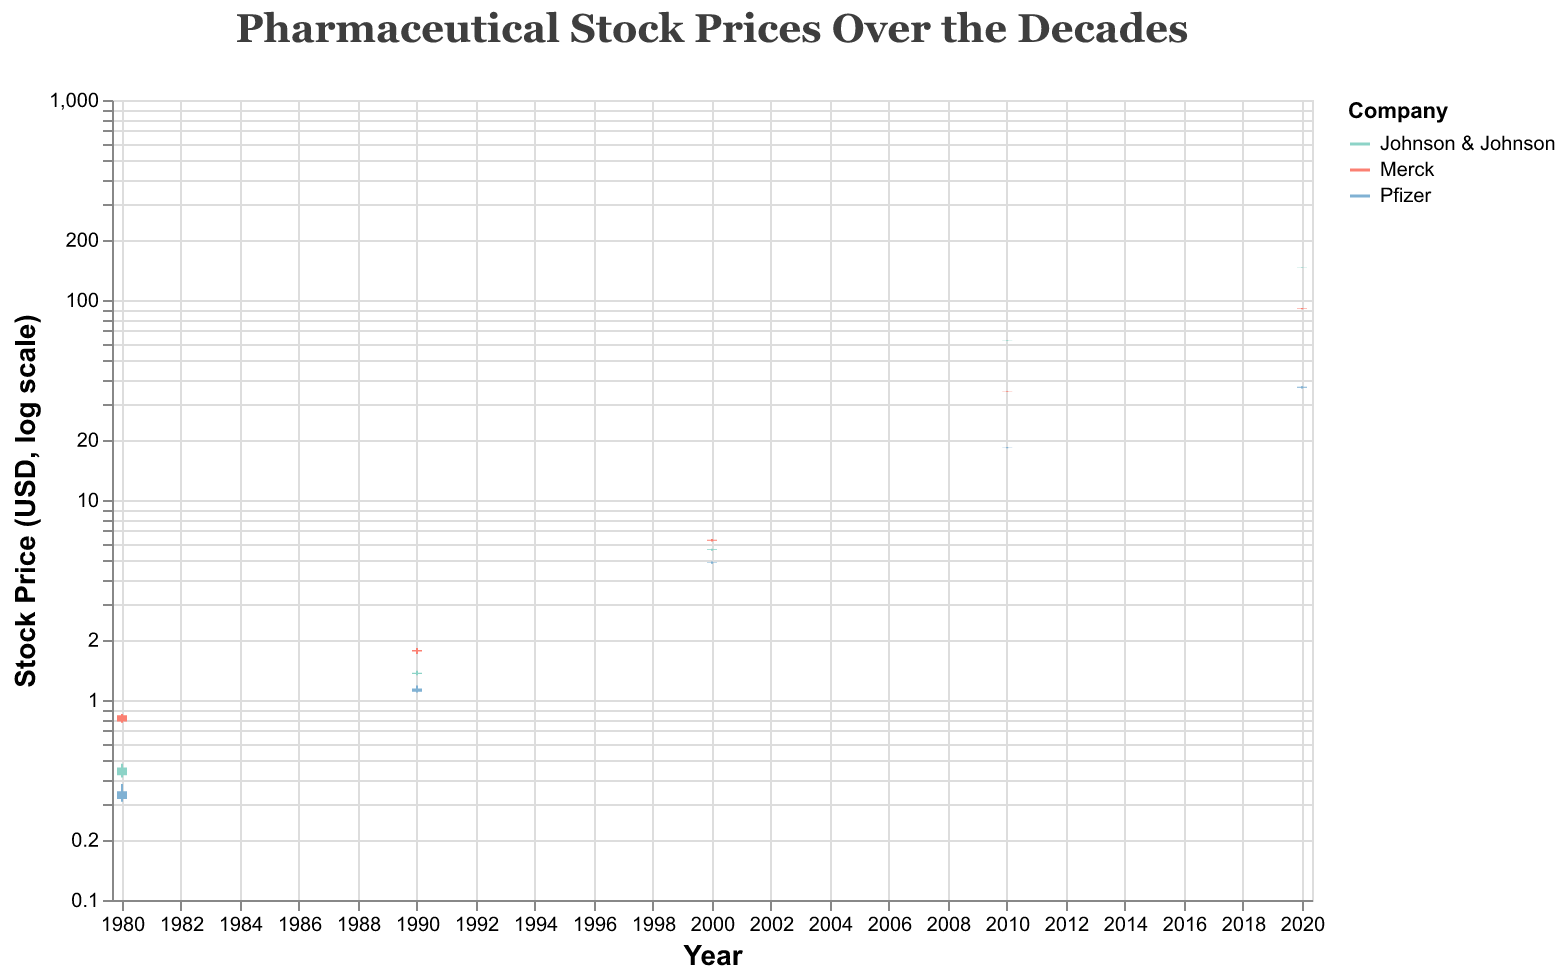What are the three companies displayed in the chart? The legend in the figure shows three different colors representing three companies. The companies are Merck, Pfizer, and Johnson & Johnson.
Answer: Merck, Pfizer, Johnson & Johnson Which company had the highest stock price in 2020? Looking at the candlesticks for 2020, Johnson & Johnson's stock reached the highest close at around $145.20 compared to Merck and Pfizer.
Answer: Johnson & Johnson In which year did Merck's stock price increase the most compared to the previous decade? Comparing the stock prices of Merck across the years: from 0.84 (1980) to 1.78 (1990), 6.32 (2000), 34.85 (2010), and 90.75 (2020). The largest increase is observed between 1990 and 2000. Calculation: $6.32 - $1.78 = $4.54$, which is higher than increases between other decades.
Answer: 2000 How does Pfizer's stock price in 2010 compare to its price in 1980? In 1980, Pfizer's closing price was 0.35 USD, and in 2010, it increased to 18.32 USD. To get the difference, we subtract 0.35 from 18.32, which results in an increase of $17.97.
Answer: $17.97 increase What is the trend of Johnson & Johnson stock prices over the decades shown? Observing the closing prices for Johnson & Johnson: 0.46 (1980), 1.37 (1990), 5.67 (2000), 62.95 (2010), and 145.20 (2020). There is a consistent upward trend in stock prices over the decades.
Answer: Upward trend What is the percentage increase in stock price for Johnson & Johnson from 2000 to 2010? In 2000, the closing price was 5.67, and in 2010 it was 62.95. The percentage increase is calculated as: ((62.95 - 5.67) / 5.67) * 100 = 1010.92%.
Answer: 1010.92% Which company's stock had the smallest growth from 1980 to 1990 in absolute terms? Merck's stock grew from 0.84 to 1.78 ($0.94), Pfizer from 0.35 to 1.14 ($0.79), and Johnson & Johnson from 0.46 to 1.37 ($0.91). Pfizer had the smallest absolute growth.
Answer: Pfizer In 2020, which company had the most volatile stock price? Stock volatility in candlestick plots can be visualized by the range between high and low. In 2020, Johnson & Johnson's stock ranges from 144.50 to 145.55, indicating the smallest range among the companies. Pfzer ranges from 36.10 to 37.00 and Merck ranges from 89.95 to 91.08. Thus, Pfizer had the most volatile stock price.
Answer: Pfizer How does Merck's closing stock price in 1980 compare to Pfizer's closing stock price in 1980? In 1980, Merck's closing price was 0.84 USD, while Pfizer's was 0.35 USD, showing that Merck's stock was higher by $0.49.
Answer: Merck's was higher Which company had the highest stock price high in the year 2000? On the candlestick representing 2000, the highest price peaks for each company can be compared. Johnson & Johnson had the highest peak at 5.70 USD, compared to Merck's 6.38 USD and Pfizer's 4.92 USD.
Answer: Merck 